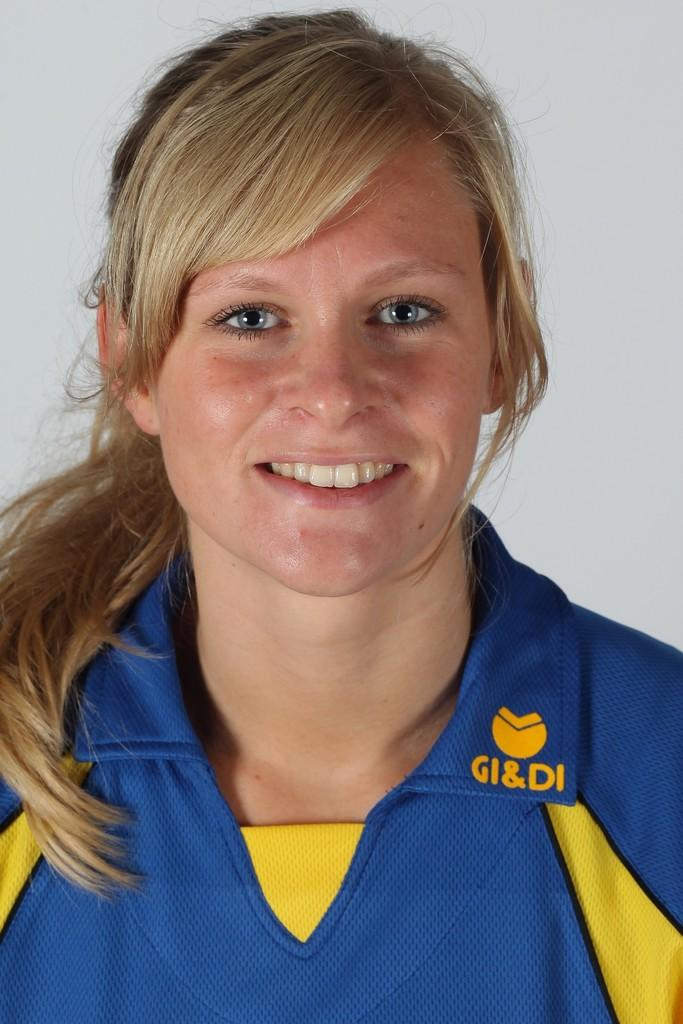<image>
Give a short and clear explanation of the subsequent image. A woman is wearing a shirt that says GI & DI on the collar. 